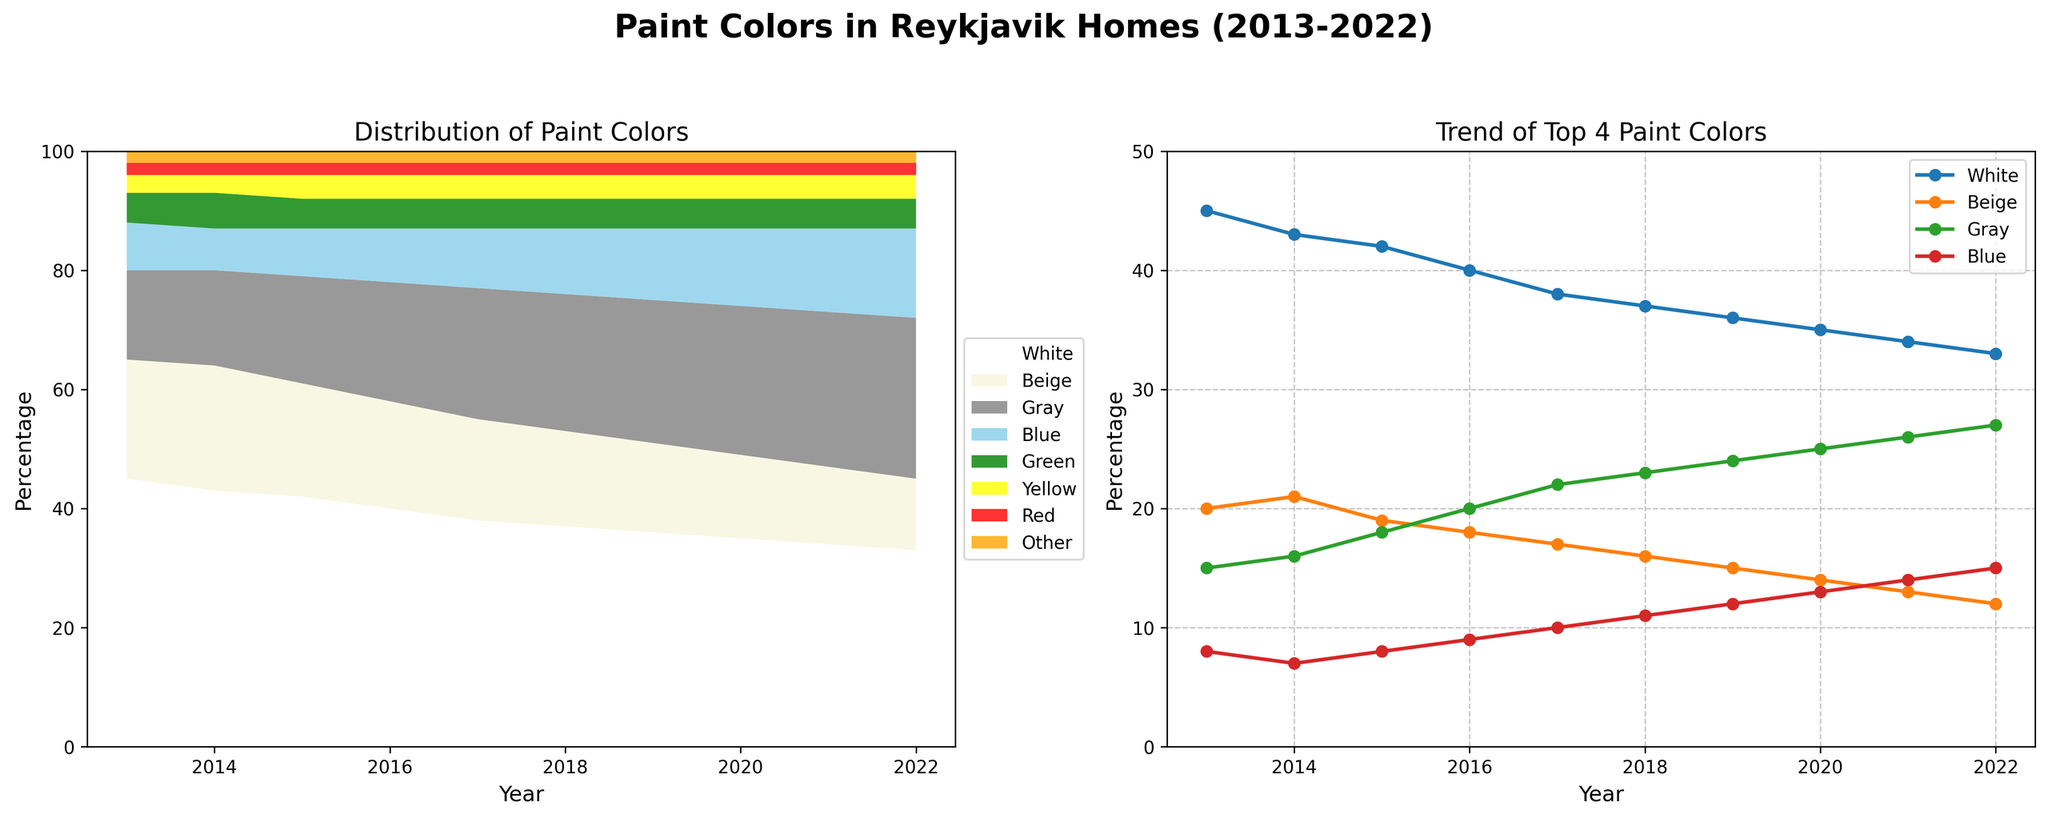What color has consistently shown a steady increase from 2013 to 2022? By examining the trends in the "Trend of Top 4 Paint Colors" line chart, it's clear that Gray is the only color that has consistently increased every year from 2013 to 2022.
Answer: Gray Which color showed a decrease in usage every year between 2013 and 2022? By looking at the line for White in the "Trend of Top 4 Paint Colors" chart, it's clear that White has decreased each year from 2013 to 2022.
Answer: White In which year does the 'Blue' color reach 15% usage in Reykjavik homes? From the line representing Blue in the "Trend of Top 4 Paint Colors" graph, it reaches 15% in the year 2022.
Answer: 2022 Out of White, Beige, Gray, and Blue, which color has the lowest usage percentage in 2022? By checking the endpoint in the "Trend of Top 4 Paint Colors" plot, Beige has the lowest percentage in 2022, which is 12%.
Answer: Beige How many colors have consistently been under 5% from 2013 to 2022? Based on the "Distribution of Paint Colors" area chart, Green, Yellow, Red, and Other have consistently been under 5% throughout the decade. Therefore, the total is four colors.
Answer: Four What are the total cumulative percentages of Blue and Gray in the year 2022? From the stacked area chart, Blue is 15% and Gray is 27% in the year 2022. Summing them together, we get 15% + 27% = 42%.
Answer: 42% Which year did Gray surpass 20% usage in Reykjavik homes for the first time? In the "Trend of Top 4 Paint Colors" plot, Gray surpasses 20% usage for the first time in the year 2016.
Answer: 2016 What is the visual trend for Beige over the years, and how does it compare to its trend for White? By observing the "Trend of Top 4 Paint Colors" chart, both Beige and White have a downward trend, but the decline in White is steeper than Beige's gradual decline.
Answer: Downward for both, White declines steeper Which year did Blue first show an increase to double digits in terms of percentage usage? By looking at the trend on the "Trend of Top 4 Paint Colors" chart, Blue first reaches double digits in 2017.
Answer: 2017 Between 2015 and 2016, how did the difference in percentages between Gray and Beige change? In the year 2015, Gray is 18% and Beige is 19%, yielding a difference of 1%. In 2016, Gray is 20% and Beige is 18%, a difference of 2%. Therefore, the change in the difference is 2% - 1% = 1%.
Answer: 1% increase 